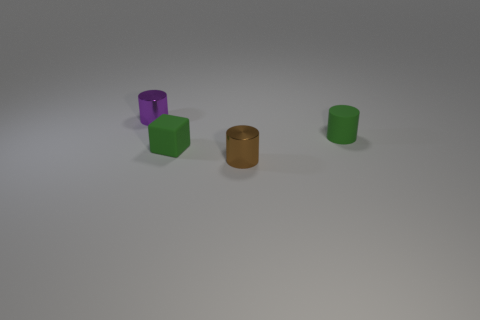Add 3 large green rubber spheres. How many objects exist? 7 Subtract all cubes. How many objects are left? 3 Add 1 tiny cylinders. How many tiny cylinders are left? 4 Add 1 brown cubes. How many brown cubes exist? 1 Subtract 1 green blocks. How many objects are left? 3 Subtract all small rubber objects. Subtract all brown metal cylinders. How many objects are left? 1 